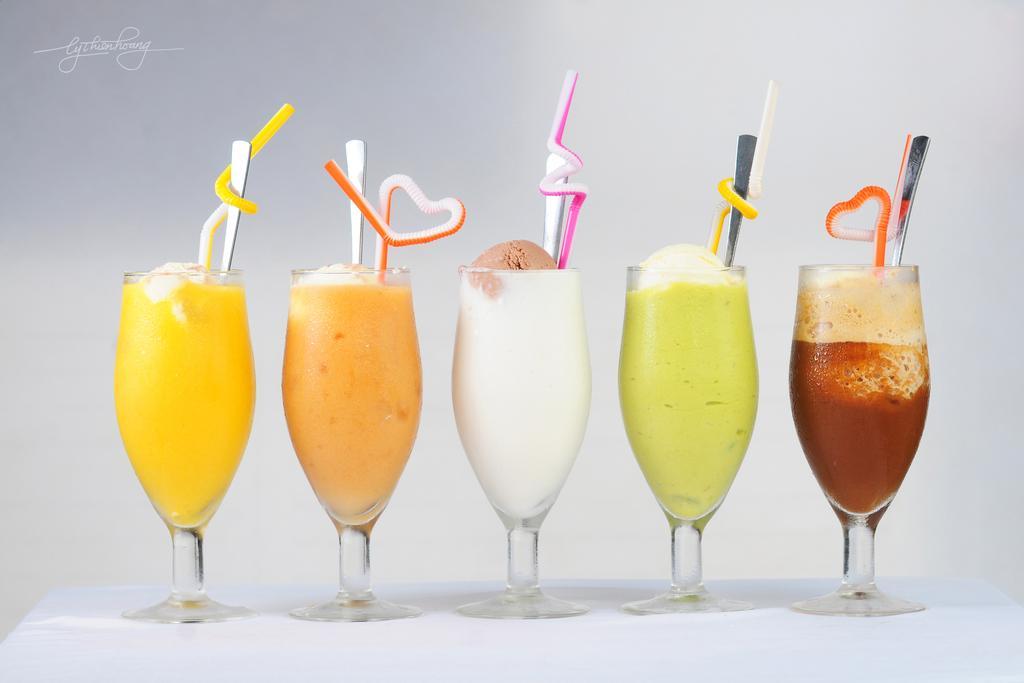Describe this image in one or two sentences. In this image we can see desserts in glasses and there are straws and spoons. At the bottom there is a table. 